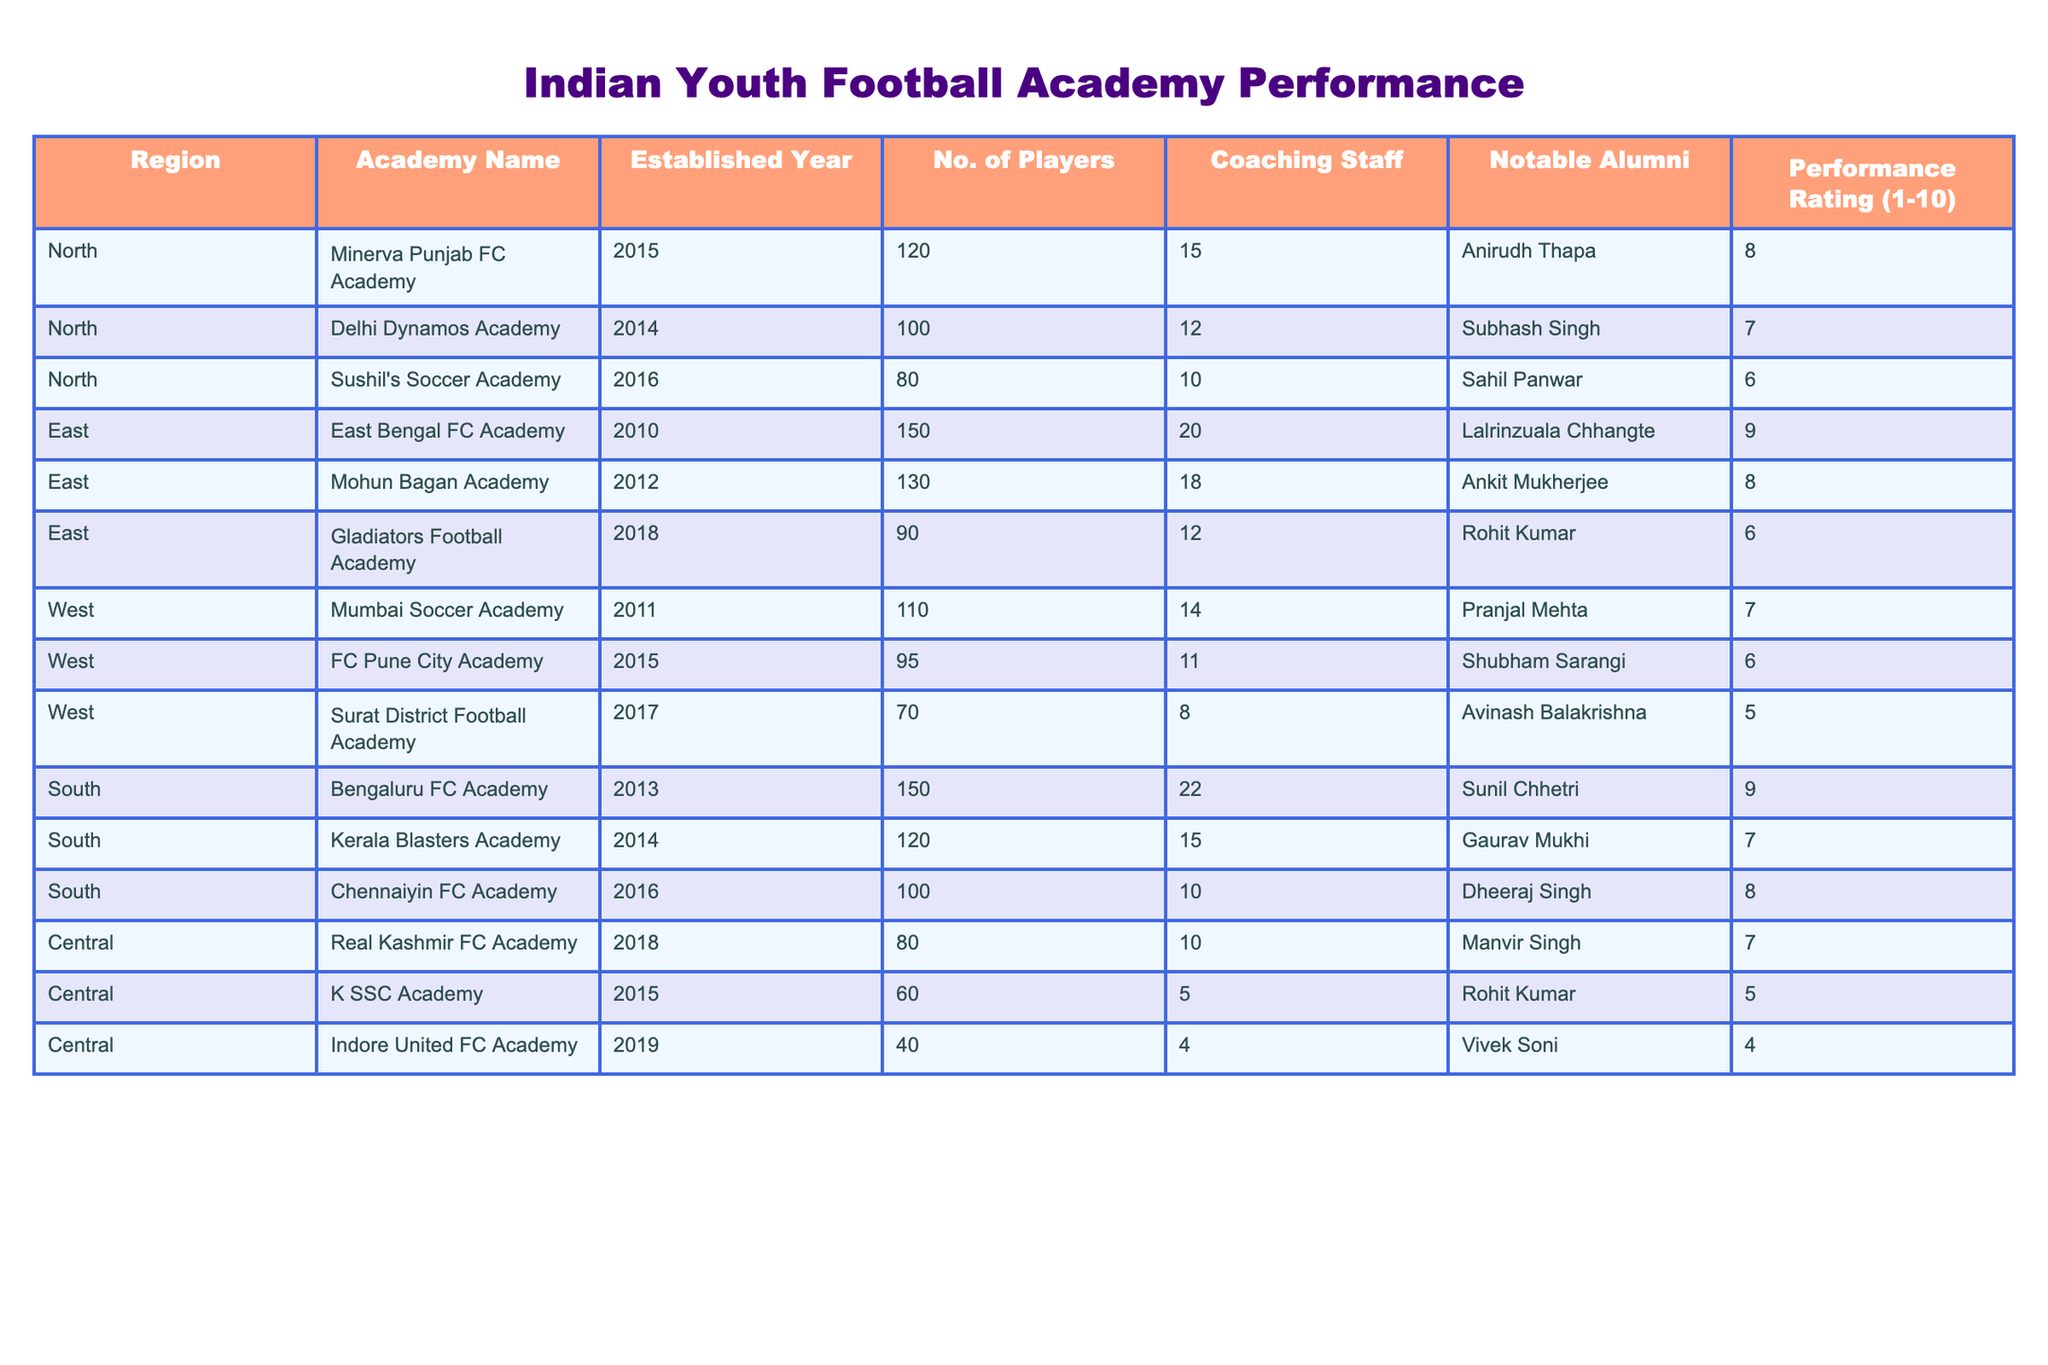What is the highest performance rating among the academies? By looking at the performance rating column, the highest value is 9, which corresponds to the East Bengal FC Academy and Bengaluru FC Academy.
Answer: 9 Which academy has the lowest number of players? The minimum number of players can be found in the 'No. of Players' column, which is 40 for the Indore United FC Academy.
Answer: 40 How many coaching staff does the Kerala Blasters Academy have? Referring to the 'Coaching Staff' column for Kerala Blasters Academy shows 15 coaching staff members.
Answer: 15 What is the average performance rating of academies in the South region? The performance ratings for South academies are 9, 7, 8. The sum is 24 and there are 3 academies. So the average is 24/3 = 8.
Answer: 8 Is it true that all academies in the East region have a performance rating greater than 5? The performance ratings for East academies are 9, 8, and 6. Since all values are above 5, this statement is true.
Answer: Yes Which region has the highest average number of players across its academies? The average number of players for each region can be calculated: North (100), East (123.33), West (91.67), South (123.33), Central (60). The highest average is therefore for the East or South regions, both with 123.33 players.
Answer: East or South How many notable alumni does the Minerva Punjab FC Academy have compared to the Mumbai Soccer Academy? Minerva Punjab FC Academy has 1 notable alumni (Anirudh Thapa) while Mumbai Soccer Academy has 1 (Pranjal Mehta). Since both have only one notable alumnus, they are equal.
Answer: Equal Which academy is the oldest and what is its performance rating? The oldest academy listed is the East Bengal FC Academy, established in 2010, with a performance rating of 9.
Answer: East Bengal FC Academy, 9 How many academies have been established after the year 2015? The academies established after 2015 are Sushil's Soccer Academy (2016), Gladiators Football Academy (2018), Bengaluru FC Academy (2013), Kerala Blasters Academy (2014), Chennaiyin FC Academy (2016), Real Kashmir FC Academy (2018), and Indore United FC Academy (2019). In total, 5 academies have been established after 2015.
Answer: 5 